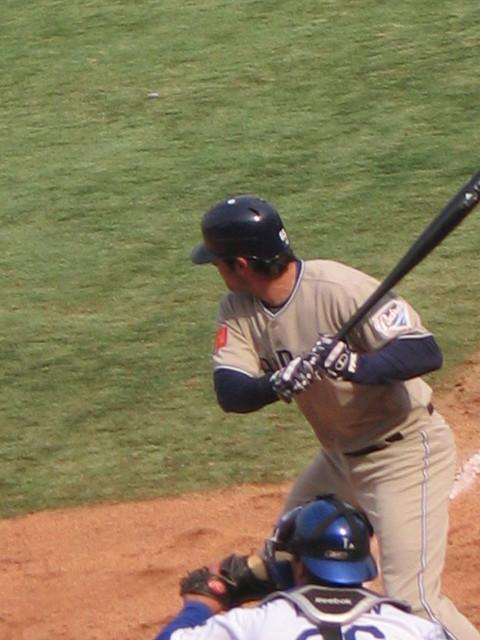Which hand is dominant in the batter shown? left 